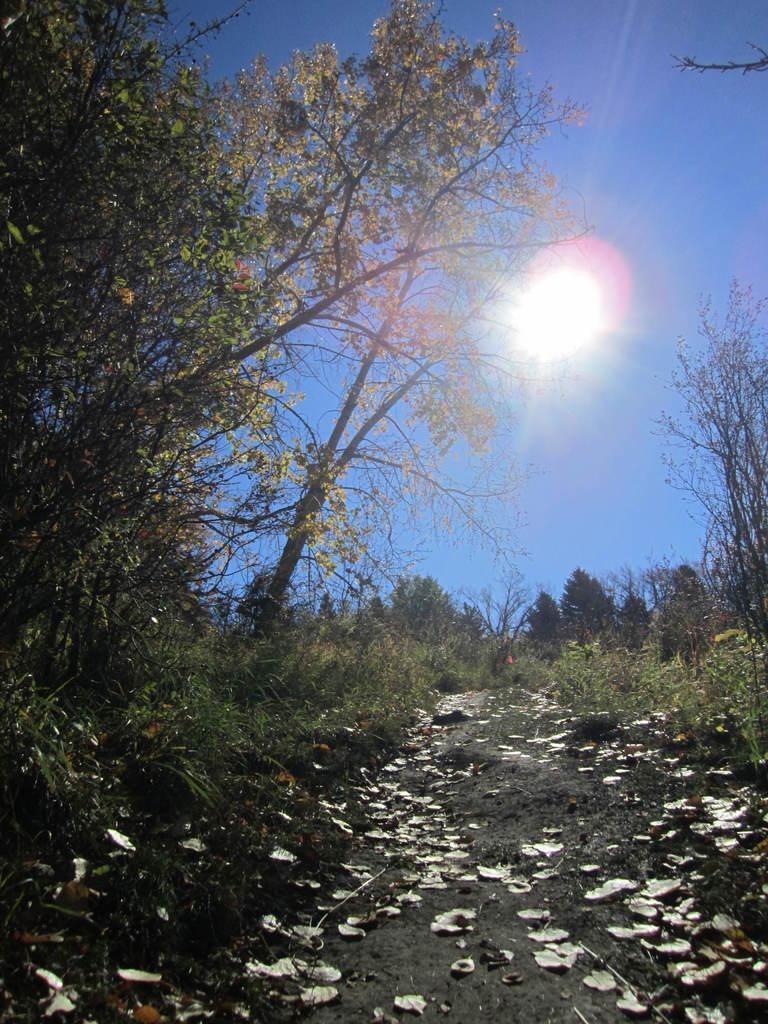How would you summarize this image in a sentence or two? At the bottom of the image on the ground there are dry leaves. And on the ground there is grass. In the image there are many trees. Behind the trees there is sky with sun. 